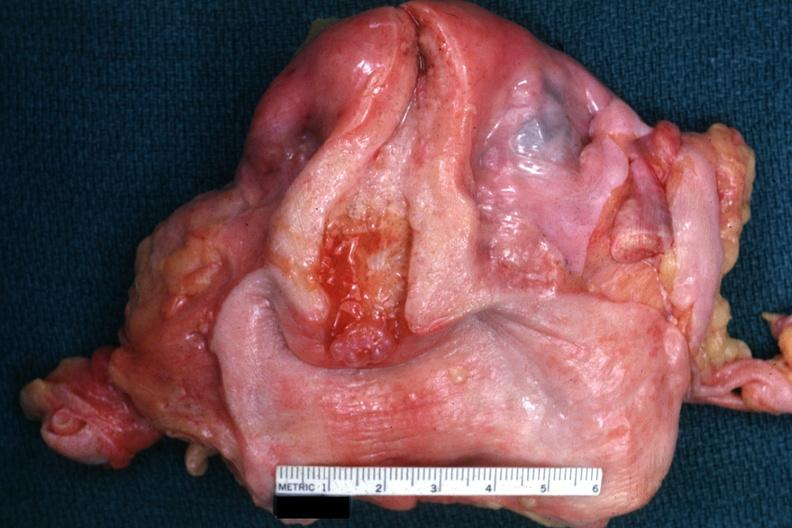what is present?
Answer the question using a single word or phrase. Female reproductive 